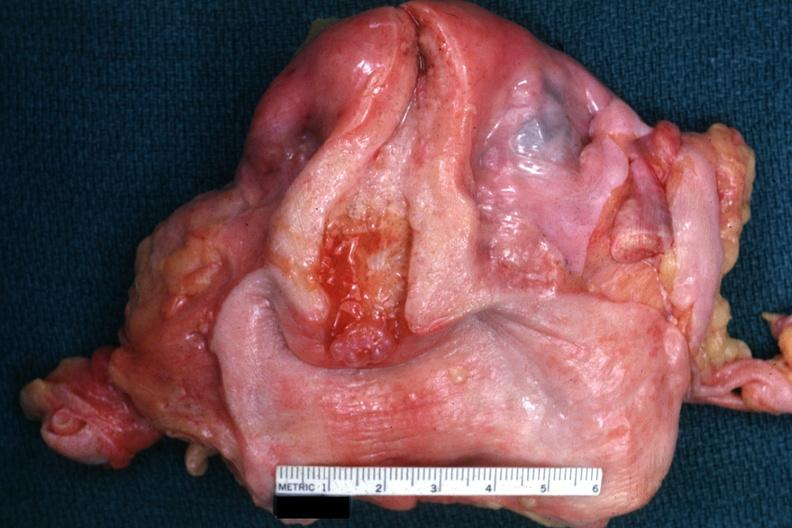what is present?
Answer the question using a single word or phrase. Female reproductive 